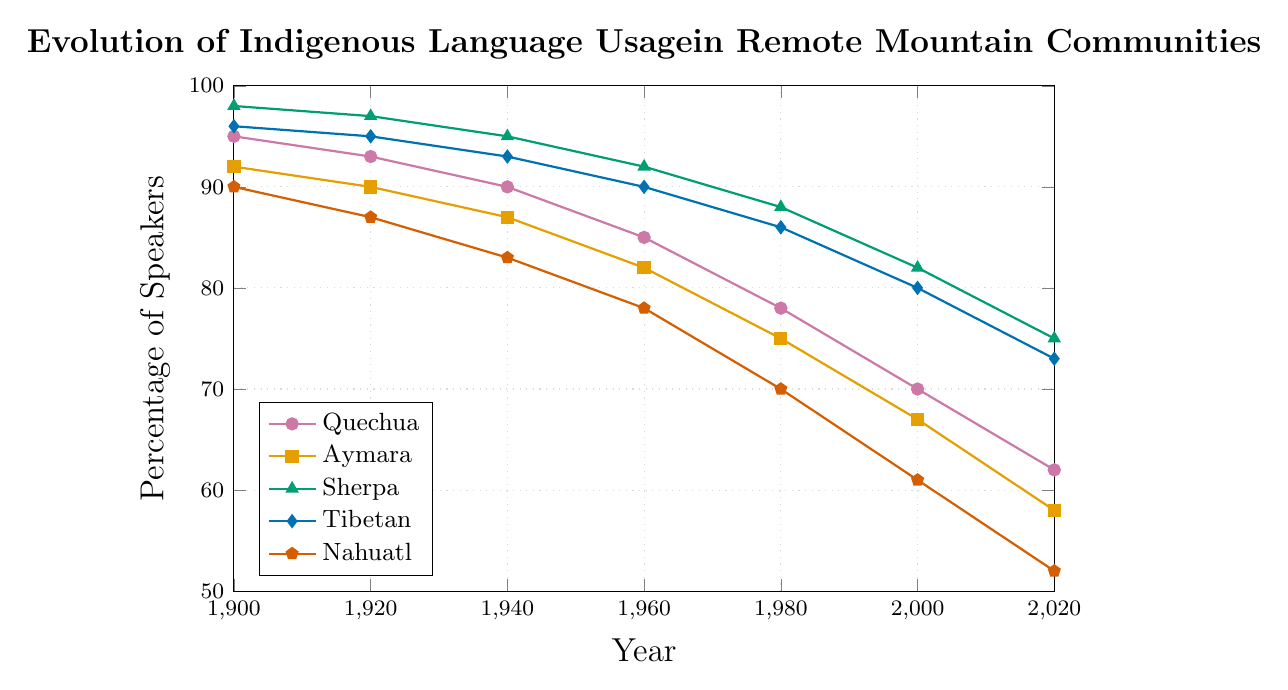Which indigenous language saw the greatest decline in percentage of speakers from 1900 to 2020? To find the greatest decline, subtract the 2020 percentage from the 1900 percentage for each language: Quechua (95-62=33), Aymara (92-58=34), Sherpa (98-75=23), Tibetan (96-73=23), Nahuatl (90-52=38). The largest decline is for Nahuatl with 38 percentage points.
Answer: Nahuatl Which language had the highest percentage of speakers in 1940? Compare the percentages in 1940 for all languages: Quechua (90), Aymara (87), Sherpa (95), Tibetan (93), Nahuatl (83). Sherpa had the highest percentage.
Answer: Sherpa What is the average percentage of speakers of Quechua across all the years shown? Add the percentages for Quechua (95+93+90+85+78+70+62=573) and divide by the number of data points (573/7).
Answer: ~81.9 Which language showed the least variation in the percentage of speakers from 1900 to 2020? Calculate the range for each language: Quechua (95-62=33), Aymara (92-58=34), Sherpa (98-75=23), Tibetan (96-73=23), Nahuatl (90-52=38). The least variation is shown by Sherpa and Tibetan both with 23 percentage points.
Answer: Sherpa and Tibetan In which year did Aymara first drop below 70%? Look at the data for Aymara: 1900 (92), 1920 (90), 1940 (87), 1960 (82), 1980 (75), 2000 (67), 2020 (58). Aymara first dropped below 70% in 2000.
Answer: 2000 By how many percentage points did the usage of Sherpa decline from 1940 to 1980? Subtract 1980 value for Sherpa from 1940 value for Sherpa: (95-88=7).
Answer: 7 Which language had the fastest decline between 1960 and 1980? Calculate the decline for each language between 1960 and 1980. Quechua: (85-78=7), Aymara: (82-75=7), Sherpa: (92-88=4), Tibetan: (90-86=4), Nahuatl: (78-70=8). Nahuatl had the fastest decline with 8 percentage points.
Answer: Nahuatl Compare the percentage of Nahuatl and Tibetan speakers in 2020. Which one is higher and by how much? Compare the percentages for Nahuatl (52) and Tibetan (73) in 2020. Tibetan is higher by (73-52=21) percentage points.
Answer: Tibetan by 21 What is the difference in the decline rates of Quechua and Aymara from 1960 to 2020? Compute the decline for Quechua: (85-62=23) and Aymara: (82-58=24), then find their difference (24-23=1).
Answer: 1 Based on the plot, which language trend showed the most stability (smallest change) from 1960 to 2000? Measure the change for each language from 1960 to 2000. Quechua: (85-70=15), Aymara: (82-67=15), Sherpa: (92-82=10), Tibetan: (90-80=10), Nahuatl: (78-61=17). Sherpa and Tibetan both showed the most stability with a change of 10 percentage points.
Answer: Sherpa and Tibetan 